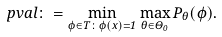Convert formula to latex. <formula><loc_0><loc_0><loc_500><loc_500>p v a l \colon = \min _ { \phi \in T \colon \phi ( x ) = 1 } \max _ { \theta \in \Theta _ { 0 } } P _ { \theta } ( \phi ) .</formula> 